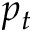Convert formula to latex. <formula><loc_0><loc_0><loc_500><loc_500>p _ { t }</formula> 